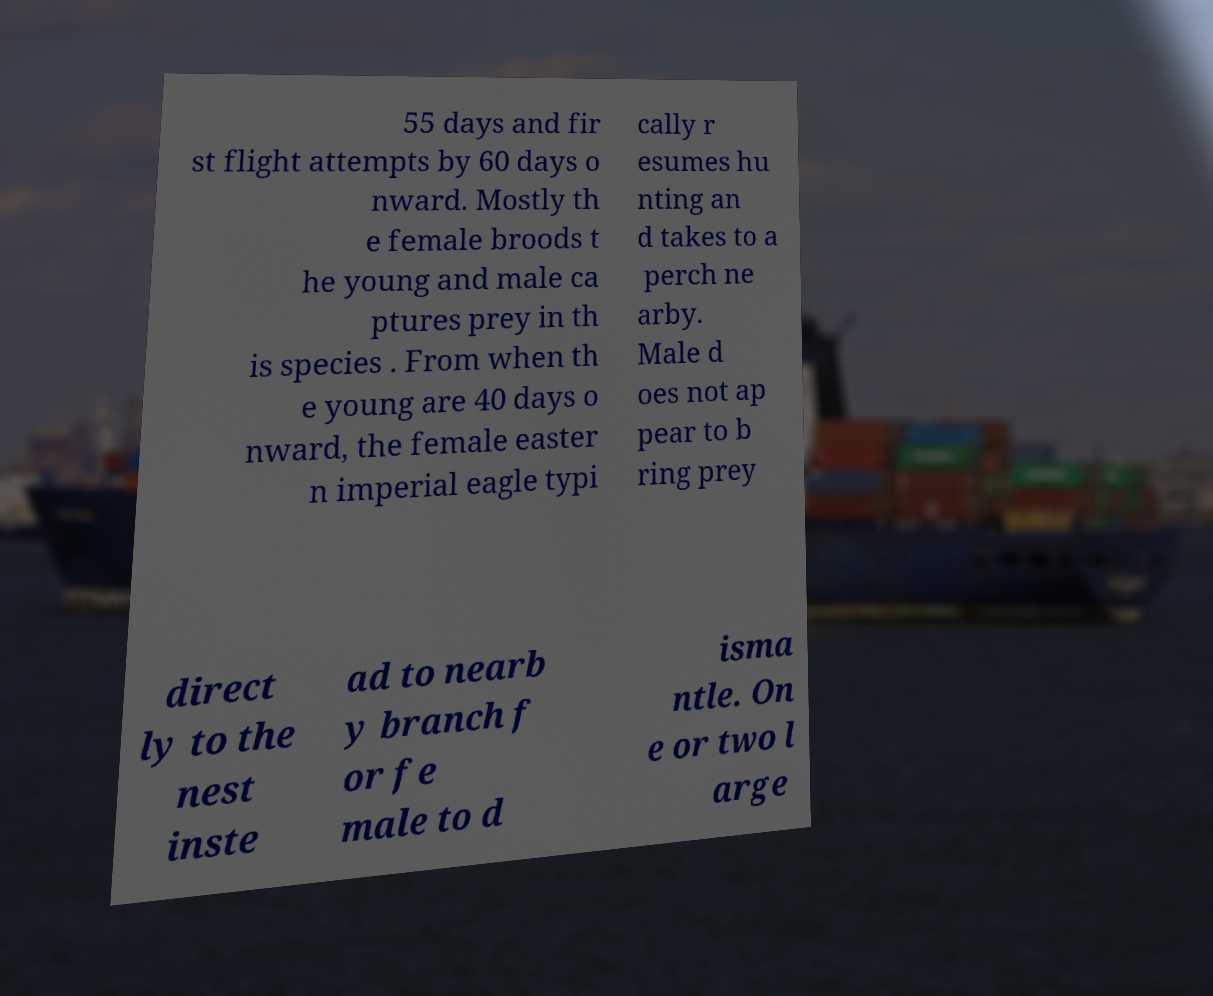Can you read and provide the text displayed in the image?This photo seems to have some interesting text. Can you extract and type it out for me? 55 days and fir st flight attempts by 60 days o nward. Mostly th e female broods t he young and male ca ptures prey in th is species . From when th e young are 40 days o nward, the female easter n imperial eagle typi cally r esumes hu nting an d takes to a perch ne arby. Male d oes not ap pear to b ring prey direct ly to the nest inste ad to nearb y branch f or fe male to d isma ntle. On e or two l arge 